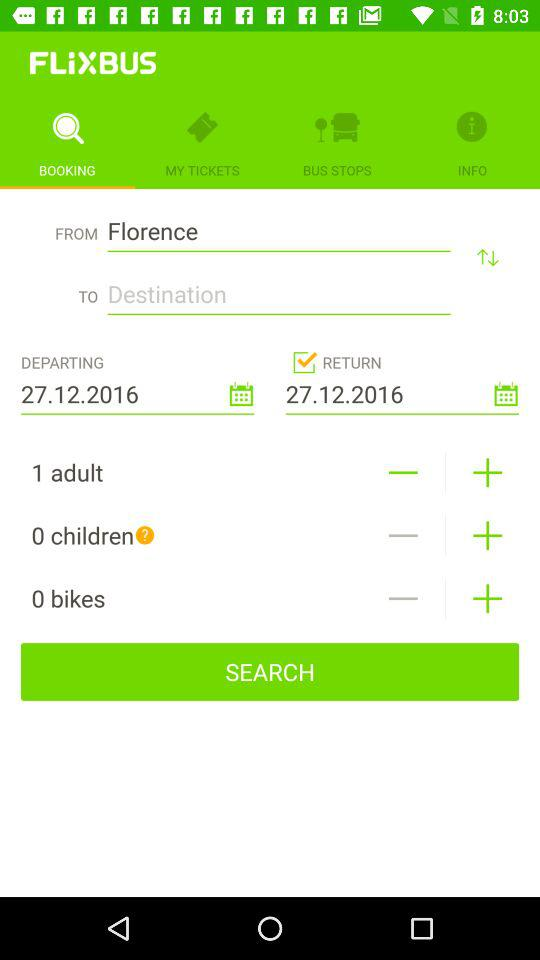Which tab is selected? The selected tab is "BOOKING". 